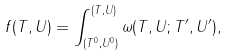Convert formula to latex. <formula><loc_0><loc_0><loc_500><loc_500>f ( T , U ) = \int ^ { ( T , U ) } _ { ( T ^ { 0 } , U ^ { 0 } ) } \omega ( T , U ; T ^ { \prime } , U ^ { \prime } ) ,</formula> 